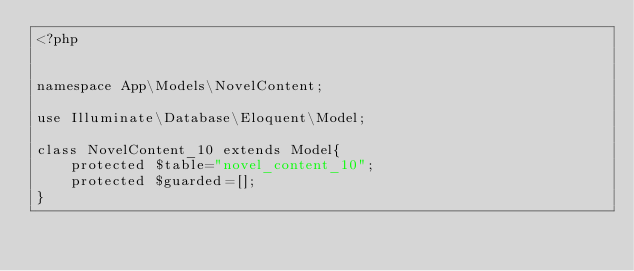<code> <loc_0><loc_0><loc_500><loc_500><_PHP_><?php


namespace App\Models\NovelContent;

use Illuminate\Database\Eloquent\Model;

class NovelContent_10 extends Model{
    protected $table="novel_content_10";
    protected $guarded=[];
}</code> 